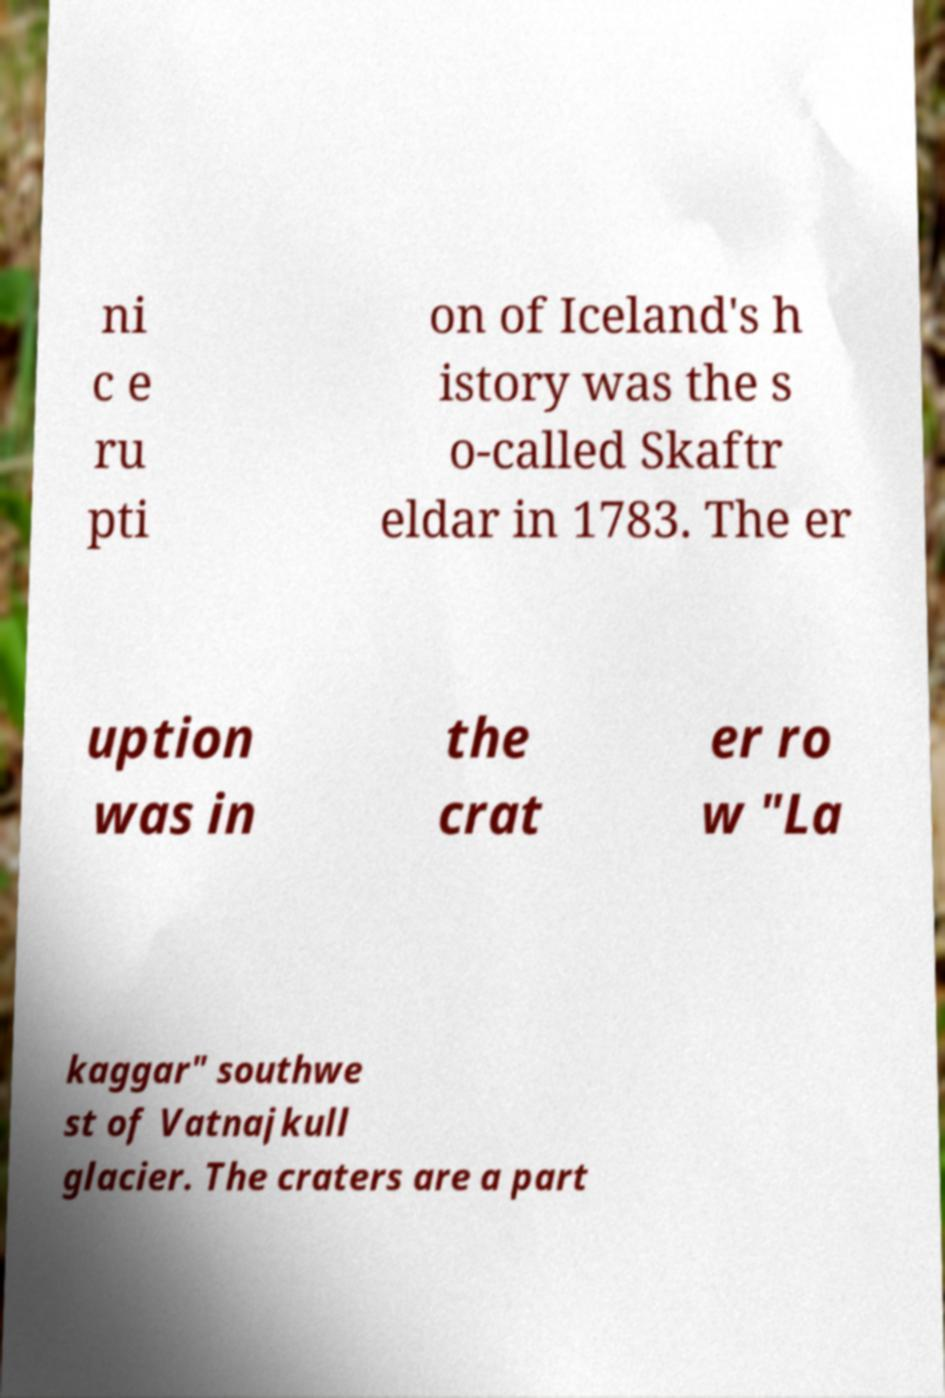I need the written content from this picture converted into text. Can you do that? ni c e ru pti on of Iceland's h istory was the s o-called Skaftr eldar in 1783. The er uption was in the crat er ro w "La kaggar" southwe st of Vatnajkull glacier. The craters are a part 